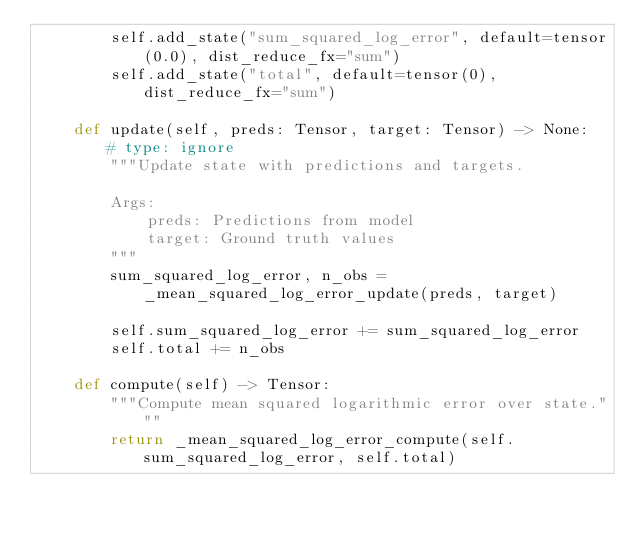Convert code to text. <code><loc_0><loc_0><loc_500><loc_500><_Python_>        self.add_state("sum_squared_log_error", default=tensor(0.0), dist_reduce_fx="sum")
        self.add_state("total", default=tensor(0), dist_reduce_fx="sum")

    def update(self, preds: Tensor, target: Tensor) -> None:  # type: ignore
        """Update state with predictions and targets.

        Args:
            preds: Predictions from model
            target: Ground truth values
        """
        sum_squared_log_error, n_obs = _mean_squared_log_error_update(preds, target)

        self.sum_squared_log_error += sum_squared_log_error
        self.total += n_obs

    def compute(self) -> Tensor:
        """Compute mean squared logarithmic error over state."""
        return _mean_squared_log_error_compute(self.sum_squared_log_error, self.total)
</code> 